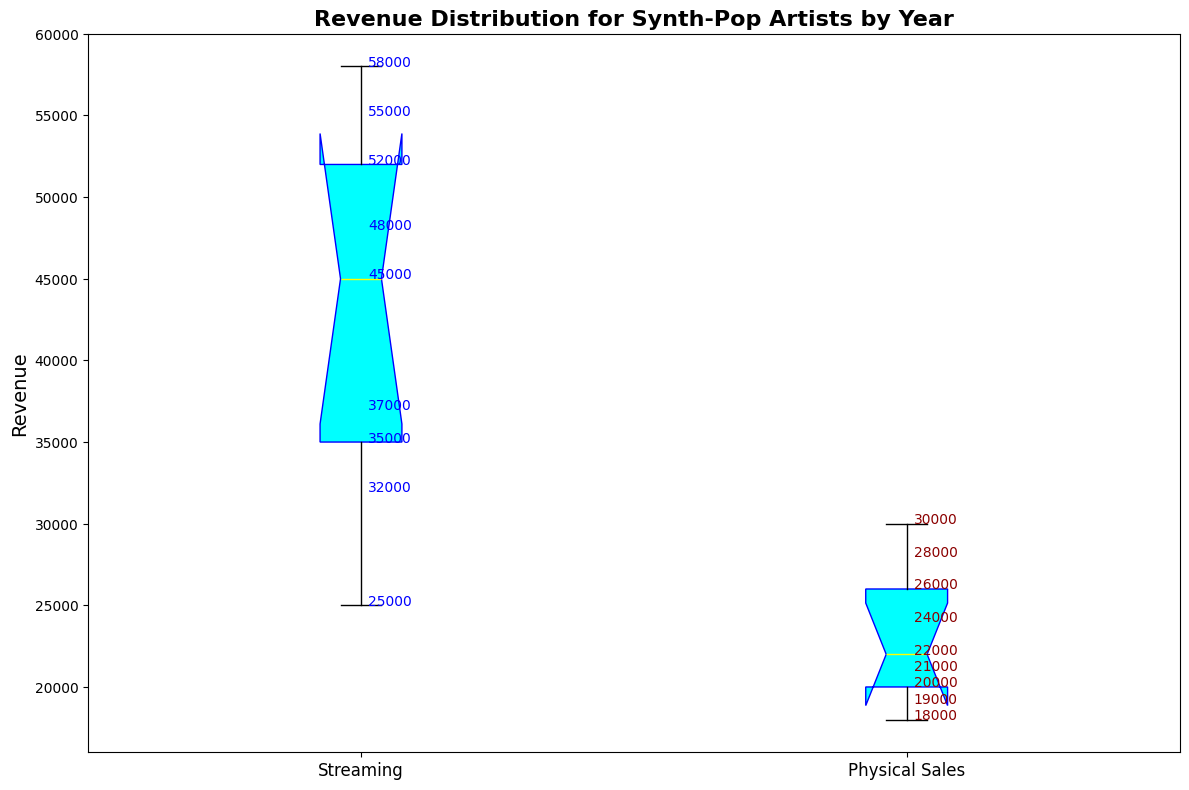What are the median revenues for Streaming and Physical Sales? The box plot shows the median value as a line inside each box. Let's observe the medians for each category. The median revenue for Streaming is approximately 48,000, and for Physical Sales, it is approximately 22,000.
Answer: 48,000 for Streaming, 22,000 for Physical Sales Which revenue type has the highest variability? The variability or spread of the data is indicated by the length of the box and whiskers. The box for Streaming is taller and stretches over a larger range, indicating higher variability compared to Physical Sales.
Answer: Streaming Between Streaming and Physical Sales, which one had the highest revenue and in what year? The highest point on the Streaming box plot is 58,000, occurring in 2023. For Physical Sales, the highest point is 30,000, occurring in 2015. The highest revenue overall is thus from Streaming in 2023.
Answer: Streaming in 2023 What is the interquartile range (IQR) for Physical Sales? The IQR is measured by the length of the box in a box plot. For Physical Sales, the box ranges from about 19000 (Q1) to 26000 (Q3). The IQR is thus Q3 - Q1 = 26000 - 19000 = 7000.
Answer: 7,000 How do the whisker lengths compare between Streaming and Physical Sales? The whiskers, representing the range of the data, for Streaming extend from about 25,000 to 58,000, while those for Physical Sales extend from about 18,000 to 30,000. The whiskers for Streaming cover a wider range, indicating a greater spread.
Answer: Streaming has longer whiskers What is the range between the minimum and maximum revenue for Streaming? The range is calculated by finding the difference between the maximum and minimum values. For Streaming, the maximum value is 58,000, and the minimum is roughly 25,000. So, the range is 58,000 - 25,000 = 33,000.
Answer: 33,000 In which revenue type are the outliers more dispersed? Outliers are represented by small circles outside the whiskers. For Streaming, there are no noticeable outliers. For Physical Sales, there are no outliers depicted. Hence, there is no outlier more dispersed in either category.
Answer: No outliers Are there any overlap in the revenues of Streaming and Physical Sales? By visually examining the height of the boxes, one can see that the highest revenue of Physical Sales does not overlap with the lowest revenue of Streaming. All values for Streaming are higher than those for Physical Sales.
Answer: No From the figure, which revenue type seems to have consistent decline in minimum annual revenue over the years? Observing the whiskers, the minimum revenue for Physical Sales shows a consistent downward trend from around 30,000 in 2015 to around 18,000 in 2023, whereas Streaming shows an increase or stabilization.
Answer: Physical Sales 